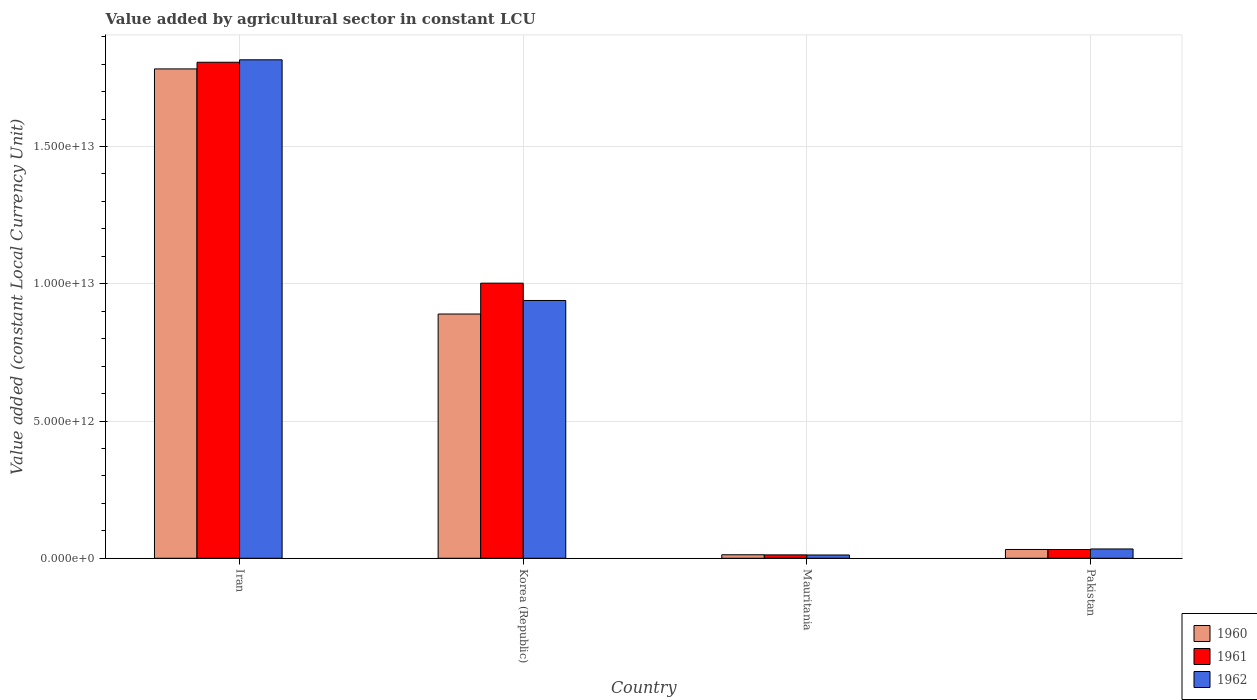How many different coloured bars are there?
Your response must be concise. 3. Are the number of bars per tick equal to the number of legend labels?
Your answer should be very brief. Yes. Are the number of bars on each tick of the X-axis equal?
Offer a very short reply. Yes. What is the label of the 1st group of bars from the left?
Provide a short and direct response. Iran. In how many cases, is the number of bars for a given country not equal to the number of legend labels?
Offer a terse response. 0. What is the value added by agricultural sector in 1960 in Korea (Republic)?
Ensure brevity in your answer.  8.90e+12. Across all countries, what is the maximum value added by agricultural sector in 1960?
Your response must be concise. 1.78e+13. Across all countries, what is the minimum value added by agricultural sector in 1961?
Offer a terse response. 1.23e+11. In which country was the value added by agricultural sector in 1960 maximum?
Ensure brevity in your answer.  Iran. In which country was the value added by agricultural sector in 1960 minimum?
Your response must be concise. Mauritania. What is the total value added by agricultural sector in 1962 in the graph?
Offer a terse response. 2.80e+13. What is the difference between the value added by agricultural sector in 1961 in Korea (Republic) and that in Mauritania?
Give a very brief answer. 9.90e+12. What is the difference between the value added by agricultural sector in 1961 in Iran and the value added by agricultural sector in 1960 in Pakistan?
Keep it short and to the point. 1.77e+13. What is the average value added by agricultural sector in 1962 per country?
Offer a terse response. 7.00e+12. What is the difference between the value added by agricultural sector of/in 1961 and value added by agricultural sector of/in 1960 in Korea (Republic)?
Keep it short and to the point. 1.12e+12. What is the ratio of the value added by agricultural sector in 1962 in Iran to that in Mauritania?
Provide a succinct answer. 151.8. Is the value added by agricultural sector in 1961 in Iran less than that in Mauritania?
Ensure brevity in your answer.  No. Is the difference between the value added by agricultural sector in 1961 in Iran and Pakistan greater than the difference between the value added by agricultural sector in 1960 in Iran and Pakistan?
Your answer should be very brief. Yes. What is the difference between the highest and the second highest value added by agricultural sector in 1961?
Give a very brief answer. 1.78e+13. What is the difference between the highest and the lowest value added by agricultural sector in 1961?
Your response must be concise. 1.79e+13. Is the sum of the value added by agricultural sector in 1961 in Iran and Korea (Republic) greater than the maximum value added by agricultural sector in 1960 across all countries?
Ensure brevity in your answer.  Yes. What does the 1st bar from the left in Iran represents?
Your answer should be compact. 1960. Is it the case that in every country, the sum of the value added by agricultural sector in 1961 and value added by agricultural sector in 1962 is greater than the value added by agricultural sector in 1960?
Give a very brief answer. Yes. How many bars are there?
Offer a very short reply. 12. Are all the bars in the graph horizontal?
Keep it short and to the point. No. What is the difference between two consecutive major ticks on the Y-axis?
Your response must be concise. 5.00e+12. How are the legend labels stacked?
Offer a very short reply. Vertical. What is the title of the graph?
Provide a short and direct response. Value added by agricultural sector in constant LCU. Does "2014" appear as one of the legend labels in the graph?
Make the answer very short. No. What is the label or title of the X-axis?
Keep it short and to the point. Country. What is the label or title of the Y-axis?
Your answer should be very brief. Value added (constant Local Currency Unit). What is the Value added (constant Local Currency Unit) in 1960 in Iran?
Your answer should be very brief. 1.78e+13. What is the Value added (constant Local Currency Unit) of 1961 in Iran?
Offer a terse response. 1.81e+13. What is the Value added (constant Local Currency Unit) of 1962 in Iran?
Your answer should be very brief. 1.82e+13. What is the Value added (constant Local Currency Unit) in 1960 in Korea (Republic)?
Give a very brief answer. 8.90e+12. What is the Value added (constant Local Currency Unit) in 1961 in Korea (Republic)?
Offer a very short reply. 1.00e+13. What is the Value added (constant Local Currency Unit) in 1962 in Korea (Republic)?
Provide a short and direct response. 9.39e+12. What is the Value added (constant Local Currency Unit) in 1960 in Mauritania?
Offer a very short reply. 1.27e+11. What is the Value added (constant Local Currency Unit) in 1961 in Mauritania?
Offer a terse response. 1.23e+11. What is the Value added (constant Local Currency Unit) in 1962 in Mauritania?
Offer a terse response. 1.20e+11. What is the Value added (constant Local Currency Unit) of 1960 in Pakistan?
Offer a very short reply. 3.20e+11. What is the Value added (constant Local Currency Unit) of 1961 in Pakistan?
Keep it short and to the point. 3.19e+11. What is the Value added (constant Local Currency Unit) of 1962 in Pakistan?
Your answer should be very brief. 3.39e+11. Across all countries, what is the maximum Value added (constant Local Currency Unit) of 1960?
Provide a succinct answer. 1.78e+13. Across all countries, what is the maximum Value added (constant Local Currency Unit) of 1961?
Offer a terse response. 1.81e+13. Across all countries, what is the maximum Value added (constant Local Currency Unit) in 1962?
Offer a terse response. 1.82e+13. Across all countries, what is the minimum Value added (constant Local Currency Unit) of 1960?
Give a very brief answer. 1.27e+11. Across all countries, what is the minimum Value added (constant Local Currency Unit) of 1961?
Your answer should be compact. 1.23e+11. Across all countries, what is the minimum Value added (constant Local Currency Unit) of 1962?
Keep it short and to the point. 1.20e+11. What is the total Value added (constant Local Currency Unit) of 1960 in the graph?
Offer a very short reply. 2.72e+13. What is the total Value added (constant Local Currency Unit) of 1961 in the graph?
Provide a succinct answer. 2.85e+13. What is the total Value added (constant Local Currency Unit) of 1962 in the graph?
Ensure brevity in your answer.  2.80e+13. What is the difference between the Value added (constant Local Currency Unit) of 1960 in Iran and that in Korea (Republic)?
Your answer should be compact. 8.93e+12. What is the difference between the Value added (constant Local Currency Unit) of 1961 in Iran and that in Korea (Republic)?
Your response must be concise. 8.05e+12. What is the difference between the Value added (constant Local Currency Unit) of 1962 in Iran and that in Korea (Republic)?
Offer a very short reply. 8.77e+12. What is the difference between the Value added (constant Local Currency Unit) of 1960 in Iran and that in Mauritania?
Offer a terse response. 1.77e+13. What is the difference between the Value added (constant Local Currency Unit) of 1961 in Iran and that in Mauritania?
Offer a terse response. 1.79e+13. What is the difference between the Value added (constant Local Currency Unit) of 1962 in Iran and that in Mauritania?
Give a very brief answer. 1.80e+13. What is the difference between the Value added (constant Local Currency Unit) in 1960 in Iran and that in Pakistan?
Offer a terse response. 1.75e+13. What is the difference between the Value added (constant Local Currency Unit) in 1961 in Iran and that in Pakistan?
Keep it short and to the point. 1.78e+13. What is the difference between the Value added (constant Local Currency Unit) of 1962 in Iran and that in Pakistan?
Give a very brief answer. 1.78e+13. What is the difference between the Value added (constant Local Currency Unit) of 1960 in Korea (Republic) and that in Mauritania?
Provide a succinct answer. 8.77e+12. What is the difference between the Value added (constant Local Currency Unit) of 1961 in Korea (Republic) and that in Mauritania?
Offer a terse response. 9.90e+12. What is the difference between the Value added (constant Local Currency Unit) in 1962 in Korea (Republic) and that in Mauritania?
Your answer should be compact. 9.27e+12. What is the difference between the Value added (constant Local Currency Unit) of 1960 in Korea (Republic) and that in Pakistan?
Ensure brevity in your answer.  8.58e+12. What is the difference between the Value added (constant Local Currency Unit) of 1961 in Korea (Republic) and that in Pakistan?
Your answer should be very brief. 9.70e+12. What is the difference between the Value added (constant Local Currency Unit) of 1962 in Korea (Republic) and that in Pakistan?
Provide a short and direct response. 9.05e+12. What is the difference between the Value added (constant Local Currency Unit) of 1960 in Mauritania and that in Pakistan?
Make the answer very short. -1.93e+11. What is the difference between the Value added (constant Local Currency Unit) of 1961 in Mauritania and that in Pakistan?
Your answer should be compact. -1.96e+11. What is the difference between the Value added (constant Local Currency Unit) in 1962 in Mauritania and that in Pakistan?
Make the answer very short. -2.20e+11. What is the difference between the Value added (constant Local Currency Unit) of 1960 in Iran and the Value added (constant Local Currency Unit) of 1961 in Korea (Republic)?
Offer a terse response. 7.81e+12. What is the difference between the Value added (constant Local Currency Unit) of 1960 in Iran and the Value added (constant Local Currency Unit) of 1962 in Korea (Republic)?
Provide a succinct answer. 8.44e+12. What is the difference between the Value added (constant Local Currency Unit) in 1961 in Iran and the Value added (constant Local Currency Unit) in 1962 in Korea (Republic)?
Ensure brevity in your answer.  8.68e+12. What is the difference between the Value added (constant Local Currency Unit) of 1960 in Iran and the Value added (constant Local Currency Unit) of 1961 in Mauritania?
Provide a short and direct response. 1.77e+13. What is the difference between the Value added (constant Local Currency Unit) in 1960 in Iran and the Value added (constant Local Currency Unit) in 1962 in Mauritania?
Provide a succinct answer. 1.77e+13. What is the difference between the Value added (constant Local Currency Unit) in 1961 in Iran and the Value added (constant Local Currency Unit) in 1962 in Mauritania?
Ensure brevity in your answer.  1.80e+13. What is the difference between the Value added (constant Local Currency Unit) in 1960 in Iran and the Value added (constant Local Currency Unit) in 1961 in Pakistan?
Ensure brevity in your answer.  1.75e+13. What is the difference between the Value added (constant Local Currency Unit) of 1960 in Iran and the Value added (constant Local Currency Unit) of 1962 in Pakistan?
Provide a succinct answer. 1.75e+13. What is the difference between the Value added (constant Local Currency Unit) in 1961 in Iran and the Value added (constant Local Currency Unit) in 1962 in Pakistan?
Offer a terse response. 1.77e+13. What is the difference between the Value added (constant Local Currency Unit) in 1960 in Korea (Republic) and the Value added (constant Local Currency Unit) in 1961 in Mauritania?
Offer a very short reply. 8.77e+12. What is the difference between the Value added (constant Local Currency Unit) in 1960 in Korea (Republic) and the Value added (constant Local Currency Unit) in 1962 in Mauritania?
Make the answer very short. 8.78e+12. What is the difference between the Value added (constant Local Currency Unit) of 1961 in Korea (Republic) and the Value added (constant Local Currency Unit) of 1962 in Mauritania?
Ensure brevity in your answer.  9.90e+12. What is the difference between the Value added (constant Local Currency Unit) in 1960 in Korea (Republic) and the Value added (constant Local Currency Unit) in 1961 in Pakistan?
Keep it short and to the point. 8.58e+12. What is the difference between the Value added (constant Local Currency Unit) in 1960 in Korea (Republic) and the Value added (constant Local Currency Unit) in 1962 in Pakistan?
Your response must be concise. 8.56e+12. What is the difference between the Value added (constant Local Currency Unit) of 1961 in Korea (Republic) and the Value added (constant Local Currency Unit) of 1962 in Pakistan?
Keep it short and to the point. 9.68e+12. What is the difference between the Value added (constant Local Currency Unit) of 1960 in Mauritania and the Value added (constant Local Currency Unit) of 1961 in Pakistan?
Your response must be concise. -1.92e+11. What is the difference between the Value added (constant Local Currency Unit) in 1960 in Mauritania and the Value added (constant Local Currency Unit) in 1962 in Pakistan?
Your answer should be compact. -2.12e+11. What is the difference between the Value added (constant Local Currency Unit) of 1961 in Mauritania and the Value added (constant Local Currency Unit) of 1962 in Pakistan?
Offer a terse response. -2.16e+11. What is the average Value added (constant Local Currency Unit) in 1960 per country?
Provide a short and direct response. 6.79e+12. What is the average Value added (constant Local Currency Unit) in 1961 per country?
Make the answer very short. 7.13e+12. What is the average Value added (constant Local Currency Unit) in 1962 per country?
Provide a succinct answer. 7.00e+12. What is the difference between the Value added (constant Local Currency Unit) of 1960 and Value added (constant Local Currency Unit) of 1961 in Iran?
Make the answer very short. -2.42e+11. What is the difference between the Value added (constant Local Currency Unit) in 1960 and Value added (constant Local Currency Unit) in 1962 in Iran?
Your response must be concise. -3.32e+11. What is the difference between the Value added (constant Local Currency Unit) in 1961 and Value added (constant Local Currency Unit) in 1962 in Iran?
Your response must be concise. -8.95e+1. What is the difference between the Value added (constant Local Currency Unit) in 1960 and Value added (constant Local Currency Unit) in 1961 in Korea (Republic)?
Your response must be concise. -1.12e+12. What is the difference between the Value added (constant Local Currency Unit) in 1960 and Value added (constant Local Currency Unit) in 1962 in Korea (Republic)?
Ensure brevity in your answer.  -4.93e+11. What is the difference between the Value added (constant Local Currency Unit) in 1961 and Value added (constant Local Currency Unit) in 1962 in Korea (Republic)?
Offer a terse response. 6.31e+11. What is the difference between the Value added (constant Local Currency Unit) in 1960 and Value added (constant Local Currency Unit) in 1961 in Mauritania?
Provide a short and direct response. 4.01e+09. What is the difference between the Value added (constant Local Currency Unit) of 1960 and Value added (constant Local Currency Unit) of 1962 in Mauritania?
Make the answer very short. 7.67e+09. What is the difference between the Value added (constant Local Currency Unit) in 1961 and Value added (constant Local Currency Unit) in 1962 in Mauritania?
Keep it short and to the point. 3.65e+09. What is the difference between the Value added (constant Local Currency Unit) in 1960 and Value added (constant Local Currency Unit) in 1961 in Pakistan?
Your response must be concise. 6.46e+08. What is the difference between the Value added (constant Local Currency Unit) in 1960 and Value added (constant Local Currency Unit) in 1962 in Pakistan?
Your answer should be compact. -1.91e+1. What is the difference between the Value added (constant Local Currency Unit) in 1961 and Value added (constant Local Currency Unit) in 1962 in Pakistan?
Offer a very short reply. -1.97e+1. What is the ratio of the Value added (constant Local Currency Unit) in 1960 in Iran to that in Korea (Republic)?
Keep it short and to the point. 2. What is the ratio of the Value added (constant Local Currency Unit) in 1961 in Iran to that in Korea (Republic)?
Your answer should be very brief. 1.8. What is the ratio of the Value added (constant Local Currency Unit) in 1962 in Iran to that in Korea (Republic)?
Provide a succinct answer. 1.93. What is the ratio of the Value added (constant Local Currency Unit) in 1960 in Iran to that in Mauritania?
Your response must be concise. 140.05. What is the ratio of the Value added (constant Local Currency Unit) in 1961 in Iran to that in Mauritania?
Give a very brief answer. 146.57. What is the ratio of the Value added (constant Local Currency Unit) of 1962 in Iran to that in Mauritania?
Your response must be concise. 151.8. What is the ratio of the Value added (constant Local Currency Unit) in 1960 in Iran to that in Pakistan?
Provide a succinct answer. 55.7. What is the ratio of the Value added (constant Local Currency Unit) of 1961 in Iran to that in Pakistan?
Give a very brief answer. 56.57. What is the ratio of the Value added (constant Local Currency Unit) of 1962 in Iran to that in Pakistan?
Provide a succinct answer. 53.54. What is the ratio of the Value added (constant Local Currency Unit) in 1960 in Korea (Republic) to that in Mauritania?
Offer a very short reply. 69.9. What is the ratio of the Value added (constant Local Currency Unit) of 1961 in Korea (Republic) to that in Mauritania?
Give a very brief answer. 81.29. What is the ratio of the Value added (constant Local Currency Unit) of 1962 in Korea (Republic) to that in Mauritania?
Provide a short and direct response. 78.51. What is the ratio of the Value added (constant Local Currency Unit) in 1960 in Korea (Republic) to that in Pakistan?
Make the answer very short. 27.8. What is the ratio of the Value added (constant Local Currency Unit) in 1961 in Korea (Republic) to that in Pakistan?
Offer a terse response. 31.38. What is the ratio of the Value added (constant Local Currency Unit) of 1962 in Korea (Republic) to that in Pakistan?
Keep it short and to the point. 27.69. What is the ratio of the Value added (constant Local Currency Unit) in 1960 in Mauritania to that in Pakistan?
Offer a terse response. 0.4. What is the ratio of the Value added (constant Local Currency Unit) of 1961 in Mauritania to that in Pakistan?
Your answer should be compact. 0.39. What is the ratio of the Value added (constant Local Currency Unit) of 1962 in Mauritania to that in Pakistan?
Your answer should be very brief. 0.35. What is the difference between the highest and the second highest Value added (constant Local Currency Unit) of 1960?
Provide a succinct answer. 8.93e+12. What is the difference between the highest and the second highest Value added (constant Local Currency Unit) in 1961?
Ensure brevity in your answer.  8.05e+12. What is the difference between the highest and the second highest Value added (constant Local Currency Unit) of 1962?
Provide a succinct answer. 8.77e+12. What is the difference between the highest and the lowest Value added (constant Local Currency Unit) of 1960?
Make the answer very short. 1.77e+13. What is the difference between the highest and the lowest Value added (constant Local Currency Unit) in 1961?
Provide a succinct answer. 1.79e+13. What is the difference between the highest and the lowest Value added (constant Local Currency Unit) in 1962?
Provide a short and direct response. 1.80e+13. 